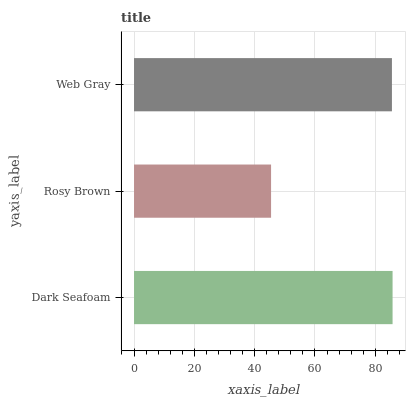Is Rosy Brown the minimum?
Answer yes or no. Yes. Is Dark Seafoam the maximum?
Answer yes or no. Yes. Is Web Gray the minimum?
Answer yes or no. No. Is Web Gray the maximum?
Answer yes or no. No. Is Web Gray greater than Rosy Brown?
Answer yes or no. Yes. Is Rosy Brown less than Web Gray?
Answer yes or no. Yes. Is Rosy Brown greater than Web Gray?
Answer yes or no. No. Is Web Gray less than Rosy Brown?
Answer yes or no. No. Is Web Gray the high median?
Answer yes or no. Yes. Is Web Gray the low median?
Answer yes or no. Yes. Is Rosy Brown the high median?
Answer yes or no. No. Is Rosy Brown the low median?
Answer yes or no. No. 